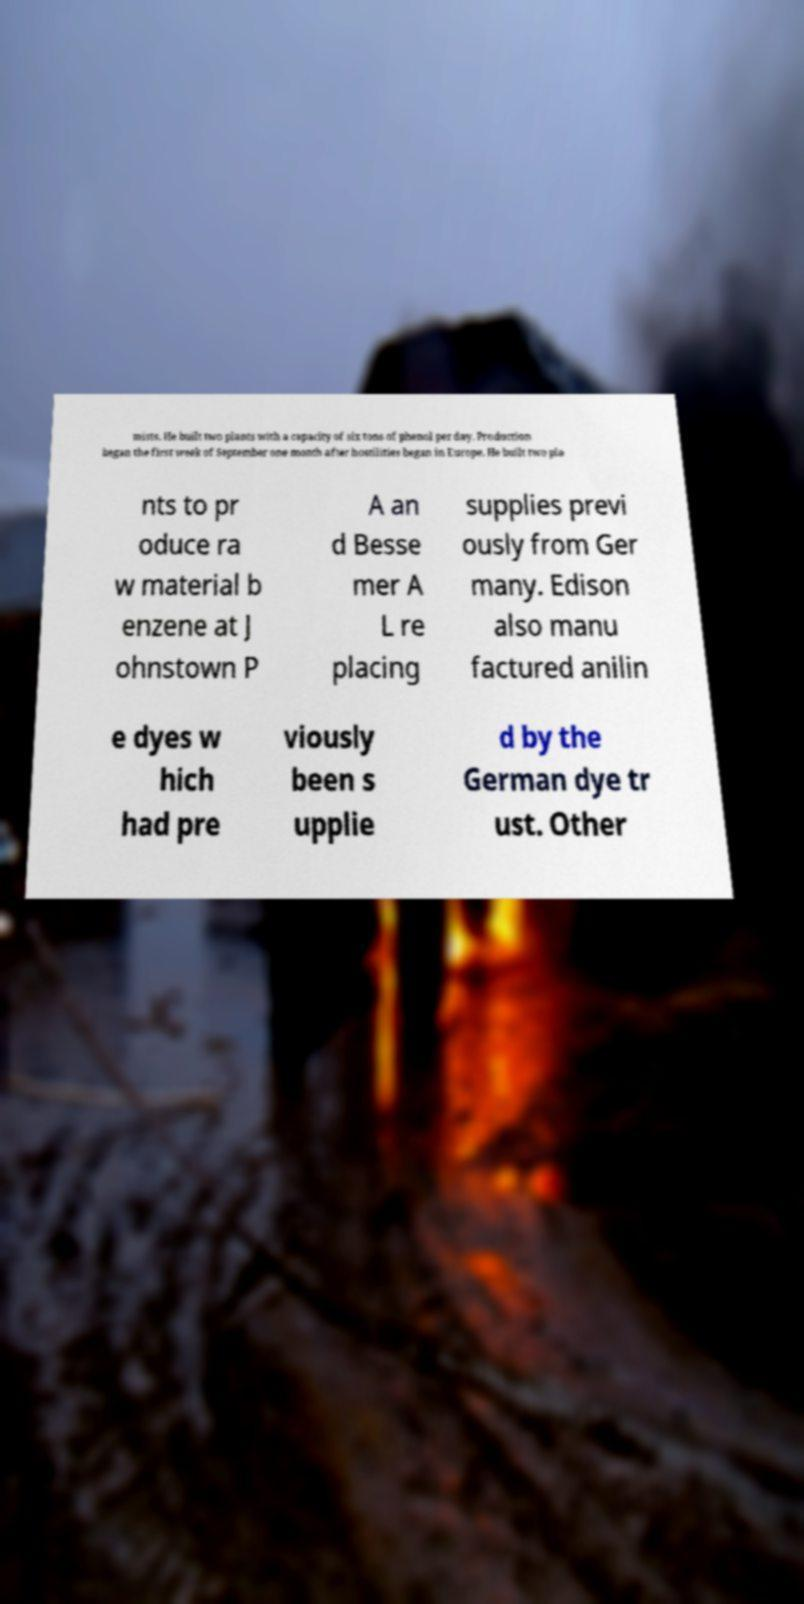Could you extract and type out the text from this image? mists. He built two plants with a capacity of six tons of phenol per day. Production began the first week of September one month after hostilities began in Europe. He built two pla nts to pr oduce ra w material b enzene at J ohnstown P A an d Besse mer A L re placing supplies previ ously from Ger many. Edison also manu factured anilin e dyes w hich had pre viously been s upplie d by the German dye tr ust. Other 